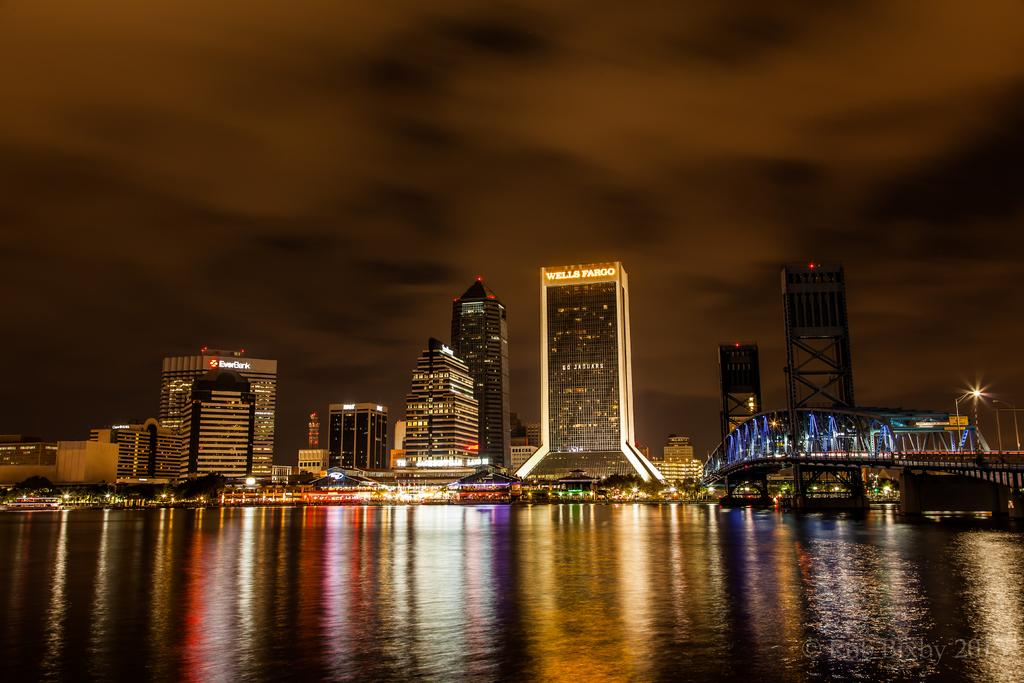<image>
Relay a brief, clear account of the picture shown. a night shot of buildings like Wells Fargo lit up at night 